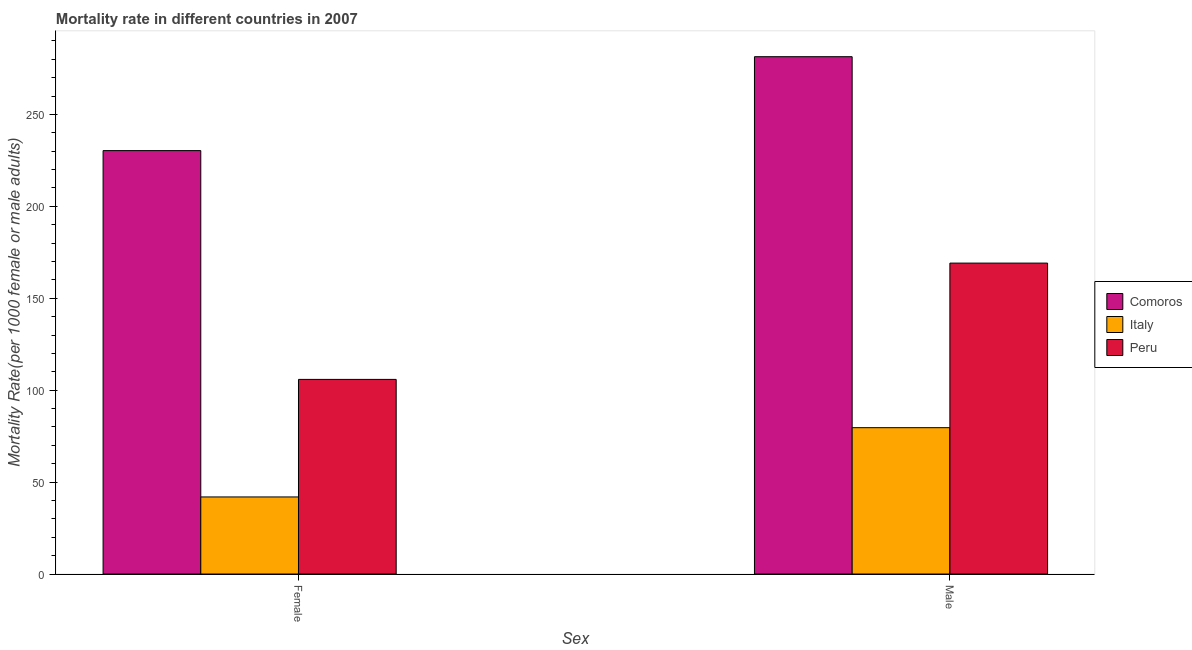Are the number of bars on each tick of the X-axis equal?
Your response must be concise. Yes. How many bars are there on the 1st tick from the left?
Offer a very short reply. 3. What is the female mortality rate in Peru?
Keep it short and to the point. 105.87. Across all countries, what is the maximum female mortality rate?
Make the answer very short. 230.34. Across all countries, what is the minimum female mortality rate?
Provide a short and direct response. 41.92. In which country was the male mortality rate maximum?
Your answer should be very brief. Comoros. In which country was the female mortality rate minimum?
Your answer should be very brief. Italy. What is the total female mortality rate in the graph?
Provide a short and direct response. 378.12. What is the difference between the male mortality rate in Comoros and that in Italy?
Provide a succinct answer. 201.82. What is the difference between the male mortality rate in Italy and the female mortality rate in Comoros?
Make the answer very short. -150.73. What is the average female mortality rate per country?
Your answer should be very brief. 126.04. What is the difference between the male mortality rate and female mortality rate in Peru?
Your answer should be very brief. 63.27. What is the ratio of the female mortality rate in Comoros to that in Italy?
Give a very brief answer. 5.49. What does the 1st bar from the left in Male represents?
Provide a succinct answer. Comoros. What does the 3rd bar from the right in Female represents?
Ensure brevity in your answer.  Comoros. Are all the bars in the graph horizontal?
Provide a succinct answer. No. What is the difference between two consecutive major ticks on the Y-axis?
Provide a short and direct response. 50. Are the values on the major ticks of Y-axis written in scientific E-notation?
Provide a succinct answer. No. Does the graph contain grids?
Your response must be concise. No. Where does the legend appear in the graph?
Offer a very short reply. Center right. What is the title of the graph?
Provide a short and direct response. Mortality rate in different countries in 2007. Does "Iraq" appear as one of the legend labels in the graph?
Keep it short and to the point. No. What is the label or title of the X-axis?
Keep it short and to the point. Sex. What is the label or title of the Y-axis?
Provide a succinct answer. Mortality Rate(per 1000 female or male adults). What is the Mortality Rate(per 1000 female or male adults) of Comoros in Female?
Provide a succinct answer. 230.34. What is the Mortality Rate(per 1000 female or male adults) of Italy in Female?
Provide a succinct answer. 41.92. What is the Mortality Rate(per 1000 female or male adults) of Peru in Female?
Your answer should be very brief. 105.87. What is the Mortality Rate(per 1000 female or male adults) in Comoros in Male?
Your answer should be very brief. 281.43. What is the Mortality Rate(per 1000 female or male adults) in Italy in Male?
Provide a succinct answer. 79.6. What is the Mortality Rate(per 1000 female or male adults) in Peru in Male?
Provide a succinct answer. 169.14. Across all Sex, what is the maximum Mortality Rate(per 1000 female or male adults) in Comoros?
Your answer should be very brief. 281.43. Across all Sex, what is the maximum Mortality Rate(per 1000 female or male adults) of Italy?
Provide a succinct answer. 79.6. Across all Sex, what is the maximum Mortality Rate(per 1000 female or male adults) in Peru?
Give a very brief answer. 169.14. Across all Sex, what is the minimum Mortality Rate(per 1000 female or male adults) in Comoros?
Keep it short and to the point. 230.34. Across all Sex, what is the minimum Mortality Rate(per 1000 female or male adults) in Italy?
Offer a very short reply. 41.92. Across all Sex, what is the minimum Mortality Rate(per 1000 female or male adults) in Peru?
Make the answer very short. 105.87. What is the total Mortality Rate(per 1000 female or male adults) in Comoros in the graph?
Make the answer very short. 511.76. What is the total Mortality Rate(per 1000 female or male adults) of Italy in the graph?
Keep it short and to the point. 121.52. What is the total Mortality Rate(per 1000 female or male adults) of Peru in the graph?
Your answer should be compact. 275.01. What is the difference between the Mortality Rate(per 1000 female or male adults) of Comoros in Female and that in Male?
Provide a succinct answer. -51.09. What is the difference between the Mortality Rate(per 1000 female or male adults) of Italy in Female and that in Male?
Ensure brevity in your answer.  -37.68. What is the difference between the Mortality Rate(per 1000 female or male adults) in Peru in Female and that in Male?
Offer a very short reply. -63.27. What is the difference between the Mortality Rate(per 1000 female or male adults) in Comoros in Female and the Mortality Rate(per 1000 female or male adults) in Italy in Male?
Ensure brevity in your answer.  150.73. What is the difference between the Mortality Rate(per 1000 female or male adults) in Comoros in Female and the Mortality Rate(per 1000 female or male adults) in Peru in Male?
Keep it short and to the point. 61.2. What is the difference between the Mortality Rate(per 1000 female or male adults) of Italy in Female and the Mortality Rate(per 1000 female or male adults) of Peru in Male?
Offer a terse response. -127.22. What is the average Mortality Rate(per 1000 female or male adults) in Comoros per Sex?
Provide a succinct answer. 255.88. What is the average Mortality Rate(per 1000 female or male adults) of Italy per Sex?
Give a very brief answer. 60.76. What is the average Mortality Rate(per 1000 female or male adults) in Peru per Sex?
Make the answer very short. 137.5. What is the difference between the Mortality Rate(per 1000 female or male adults) of Comoros and Mortality Rate(per 1000 female or male adults) of Italy in Female?
Offer a very short reply. 188.42. What is the difference between the Mortality Rate(per 1000 female or male adults) of Comoros and Mortality Rate(per 1000 female or male adults) of Peru in Female?
Your answer should be compact. 124.46. What is the difference between the Mortality Rate(per 1000 female or male adults) in Italy and Mortality Rate(per 1000 female or male adults) in Peru in Female?
Your response must be concise. -63.95. What is the difference between the Mortality Rate(per 1000 female or male adults) in Comoros and Mortality Rate(per 1000 female or male adults) in Italy in Male?
Provide a short and direct response. 201.82. What is the difference between the Mortality Rate(per 1000 female or male adults) in Comoros and Mortality Rate(per 1000 female or male adults) in Peru in Male?
Ensure brevity in your answer.  112.29. What is the difference between the Mortality Rate(per 1000 female or male adults) in Italy and Mortality Rate(per 1000 female or male adults) in Peru in Male?
Offer a terse response. -89.54. What is the ratio of the Mortality Rate(per 1000 female or male adults) of Comoros in Female to that in Male?
Your answer should be very brief. 0.82. What is the ratio of the Mortality Rate(per 1000 female or male adults) in Italy in Female to that in Male?
Offer a very short reply. 0.53. What is the ratio of the Mortality Rate(per 1000 female or male adults) of Peru in Female to that in Male?
Provide a succinct answer. 0.63. What is the difference between the highest and the second highest Mortality Rate(per 1000 female or male adults) in Comoros?
Keep it short and to the point. 51.09. What is the difference between the highest and the second highest Mortality Rate(per 1000 female or male adults) in Italy?
Your response must be concise. 37.68. What is the difference between the highest and the second highest Mortality Rate(per 1000 female or male adults) of Peru?
Your response must be concise. 63.27. What is the difference between the highest and the lowest Mortality Rate(per 1000 female or male adults) in Comoros?
Make the answer very short. 51.09. What is the difference between the highest and the lowest Mortality Rate(per 1000 female or male adults) of Italy?
Ensure brevity in your answer.  37.68. What is the difference between the highest and the lowest Mortality Rate(per 1000 female or male adults) of Peru?
Offer a very short reply. 63.27. 